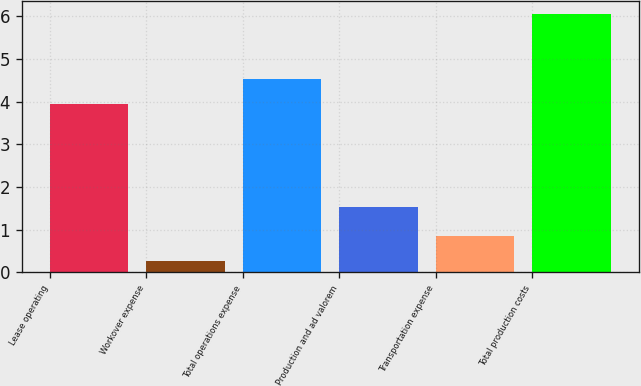<chart> <loc_0><loc_0><loc_500><loc_500><bar_chart><fcel>Lease operating<fcel>Workover expense<fcel>Total operations expense<fcel>Production and ad valorem<fcel>Transportation expense<fcel>Total production costs<nl><fcel>3.94<fcel>0.27<fcel>4.52<fcel>1.52<fcel>0.85<fcel>6.06<nl></chart> 